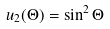Convert formula to latex. <formula><loc_0><loc_0><loc_500><loc_500>u _ { 2 } ( \Theta ) = \sin ^ { 2 } \Theta</formula> 